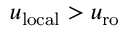<formula> <loc_0><loc_0><loc_500><loc_500>u _ { l o c a l } > u _ { r o }</formula> 